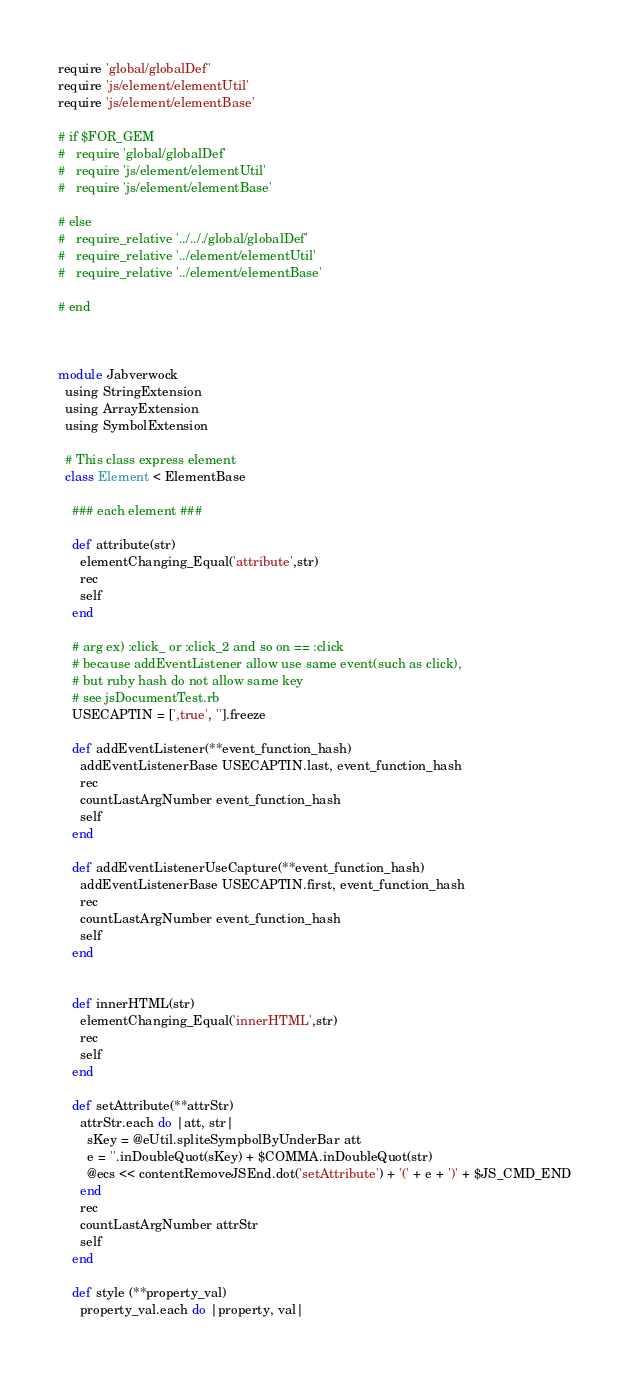<code> <loc_0><loc_0><loc_500><loc_500><_Ruby_>require 'global/globalDef'
require 'js/element/elementUtil'
require 'js/element/elementBase'

# if $FOR_GEM  
#   require 'global/globalDef'
#   require 'js/element/elementUtil'
#   require 'js/element/elementBase'
  
# else
#   require_relative '../.././global/globalDef' 
#   require_relative '../element/elementUtil'
#   require_relative '../element/elementBase'
  
# end



module Jabverwock
  using StringExtension
  using ArrayExtension
  using SymbolExtension
  
  # This class express element
  class Element < ElementBase
        
    ### each element ###

    def attribute(str)
      elementChanging_Equal('attribute',str)
      rec
      self
    end

    # arg ex) :click_ or :click_2 and so on == :click
    # because addEventListener allow use same event(such as click),
    # but ruby hash do not allow same key
    # see jsDocumentTest.rb
    USECAPTIN = [',true', ''].freeze
    
    def addEventListener(**event_function_hash)
      addEventListenerBase USECAPTIN.last, event_function_hash
      rec
      countLastArgNumber event_function_hash
      self
    end
    
    def addEventListenerUseCapture(**event_function_hash)
      addEventListenerBase USECAPTIN.first, event_function_hash
      rec
      countLastArgNumber event_function_hash
      self
    end
    

    def innerHTML(str)
      elementChanging_Equal('innerHTML',str)
      rec
      self
    end

    def setAttribute(**attrStr)
      attrStr.each do |att, str|
        sKey = @eUtil.spliteSympbolByUnderBar att 
        e = ''.inDoubleQuot(sKey) + $COMMA.inDoubleQuot(str)
        @ecs << contentRemoveJSEnd.dot('setAttribute') + '(' + e + ')' + $JS_CMD_END
      end
      rec
      countLastArgNumber attrStr
      self
    end
    
    def style (**property_val)
      property_val.each do |property, val|</code> 